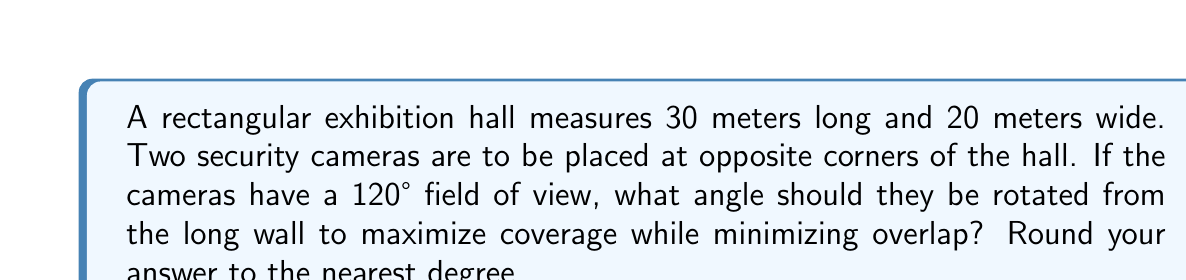Teach me how to tackle this problem. Let's approach this step-by-step:

1) First, we need to find the angle of the diagonal of the room from the long wall. We can do this using the arctangent function:

   $$\theta = \arctan(\frac{width}{length}) = \arctan(\frac{20}{30})$$

2) Convert this to degrees:
   $$\theta = \arctan(\frac{20}{30}) \cdot \frac{180}{\pi} \approx 33.69°$$

3) The optimal coverage would be achieved when each camera covers half of this angle plus half of its field of view. This way, the cameras will just meet in the middle of the room.

4) The rotation angle from the long wall would then be:

   $$\text{Rotation Angle} = \frac{\theta}{2} + \frac{120°}{4}$$

5) Substituting the values:

   $$\text{Rotation Angle} = \frac{33.69°}{2} + 30° \approx 46.845°$$

6) Rounding to the nearest degree:

   $$\text{Rotation Angle} \approx 47°$$
Answer: 47° 